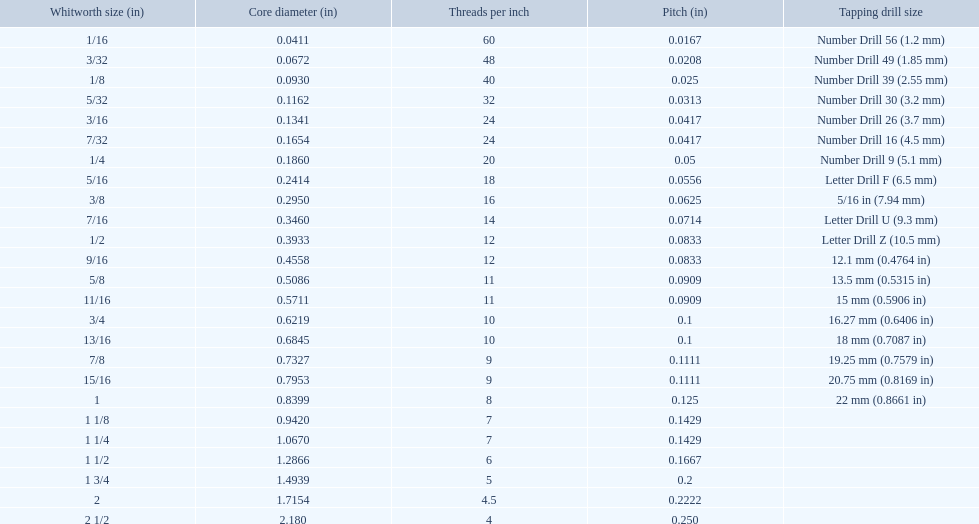What are the proportions of threads per inch? 60, 48, 40, 32, 24, 24, 20, 18, 16, 14, 12, 12, 11, 11, 10, 10, 9, 9, 8, 7, 7, 6, 5, 4.5, 4. Which whitworth proportion has just 5 threads per inch? 1 3/4. 